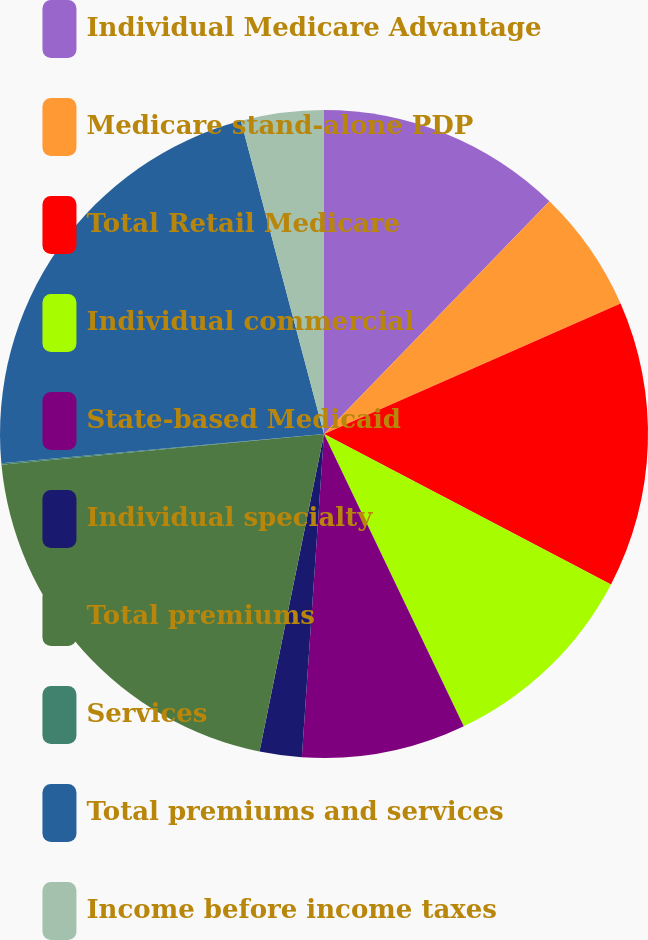Convert chart to OTSL. <chart><loc_0><loc_0><loc_500><loc_500><pie_chart><fcel>Individual Medicare Advantage<fcel>Medicare stand-alone PDP<fcel>Total Retail Medicare<fcel>Individual commercial<fcel>State-based Medicaid<fcel>Individual specialty<fcel>Total premiums<fcel>Services<fcel>Total premiums and services<fcel>Income before income taxes<nl><fcel>12.25%<fcel>6.16%<fcel>14.28%<fcel>10.22%<fcel>8.19%<fcel>2.1%<fcel>20.3%<fcel>0.07%<fcel>22.32%<fcel>4.13%<nl></chart> 